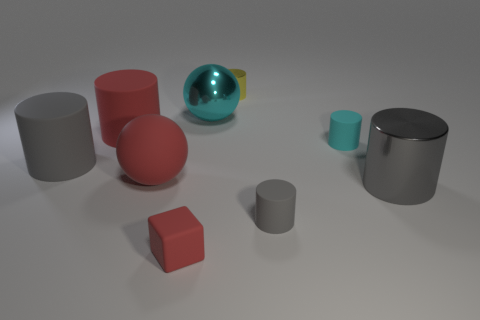Subtract all brown blocks. How many gray cylinders are left? 3 Subtract all yellow cylinders. How many cylinders are left? 5 Subtract all red cylinders. How many cylinders are left? 5 Subtract all purple cylinders. Subtract all red spheres. How many cylinders are left? 6 Add 1 big balls. How many objects exist? 10 Subtract all cubes. How many objects are left? 8 Subtract 0 gray balls. How many objects are left? 9 Subtract all cyan objects. Subtract all blue shiny cylinders. How many objects are left? 7 Add 3 cyan matte objects. How many cyan matte objects are left? 4 Add 9 big green rubber balls. How many big green rubber balls exist? 9 